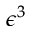<formula> <loc_0><loc_0><loc_500><loc_500>\epsilon ^ { 3 }</formula> 